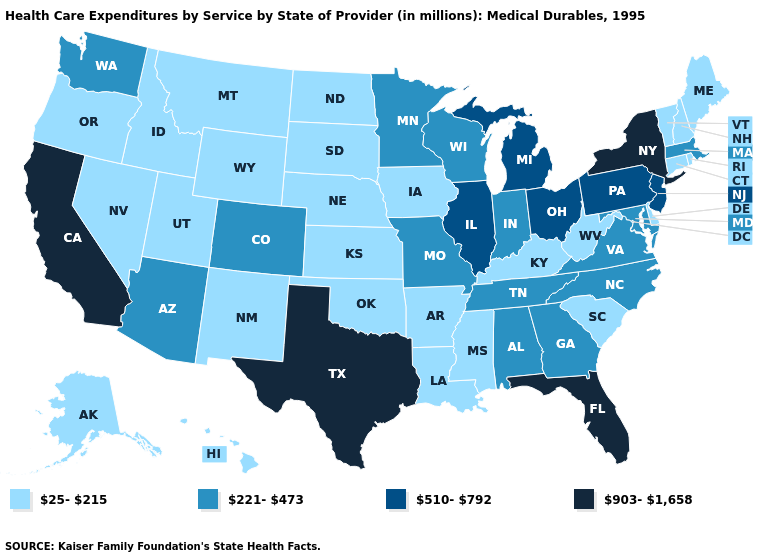What is the lowest value in the West?
Concise answer only. 25-215. Name the states that have a value in the range 510-792?
Concise answer only. Illinois, Michigan, New Jersey, Ohio, Pennsylvania. What is the value of Illinois?
Quick response, please. 510-792. What is the value of Rhode Island?
Write a very short answer. 25-215. Does Colorado have a higher value than Minnesota?
Be succinct. No. What is the value of Alaska?
Concise answer only. 25-215. Does Wisconsin have the same value as New Jersey?
Be succinct. No. Which states have the highest value in the USA?
Quick response, please. California, Florida, New York, Texas. What is the value of Texas?
Keep it brief. 903-1,658. What is the highest value in the West ?
Answer briefly. 903-1,658. Which states have the lowest value in the USA?
Concise answer only. Alaska, Arkansas, Connecticut, Delaware, Hawaii, Idaho, Iowa, Kansas, Kentucky, Louisiana, Maine, Mississippi, Montana, Nebraska, Nevada, New Hampshire, New Mexico, North Dakota, Oklahoma, Oregon, Rhode Island, South Carolina, South Dakota, Utah, Vermont, West Virginia, Wyoming. Which states hav the highest value in the South?
Be succinct. Florida, Texas. Name the states that have a value in the range 25-215?
Keep it brief. Alaska, Arkansas, Connecticut, Delaware, Hawaii, Idaho, Iowa, Kansas, Kentucky, Louisiana, Maine, Mississippi, Montana, Nebraska, Nevada, New Hampshire, New Mexico, North Dakota, Oklahoma, Oregon, Rhode Island, South Carolina, South Dakota, Utah, Vermont, West Virginia, Wyoming. Does the map have missing data?
Answer briefly. No. Which states have the lowest value in the USA?
Keep it brief. Alaska, Arkansas, Connecticut, Delaware, Hawaii, Idaho, Iowa, Kansas, Kentucky, Louisiana, Maine, Mississippi, Montana, Nebraska, Nevada, New Hampshire, New Mexico, North Dakota, Oklahoma, Oregon, Rhode Island, South Carolina, South Dakota, Utah, Vermont, West Virginia, Wyoming. 